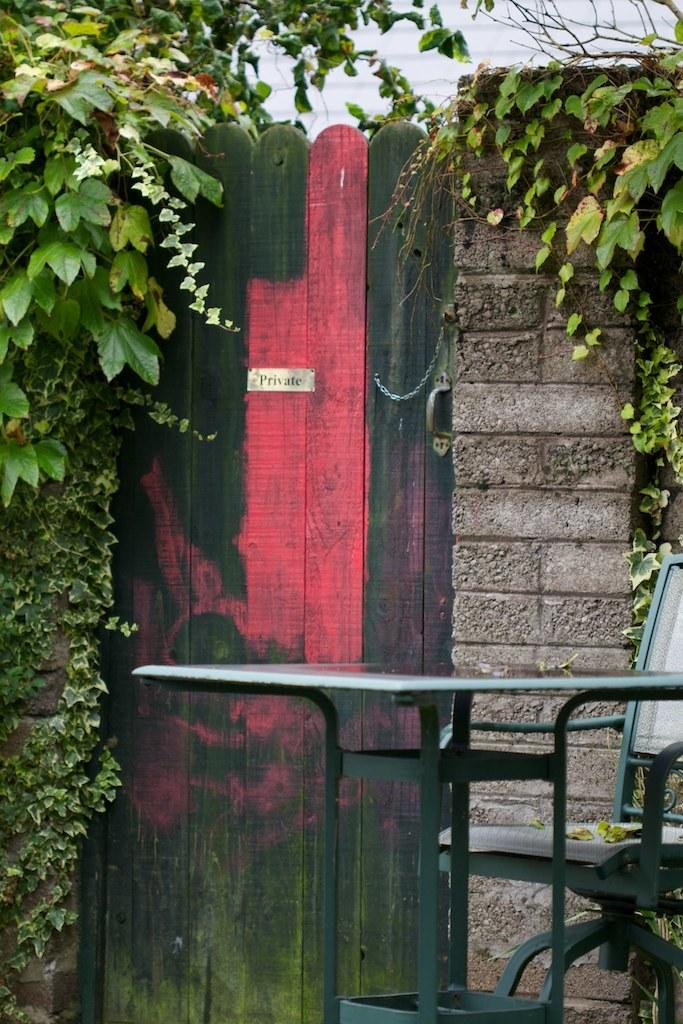What is the main object in the image? There is a door in the image. What is attached to the door? There is a chain on the door. How can the door be opened or closed? There is a door handle in the image. What can be seen on the left side of the image? There are plants on the left side of the image. What can be seen on the right side of the image? There are plants, a chair, and a table on the right side of the image. What type of neck accessory is being worn by the chair in the image? There is no neck accessory present in the image, as the chair is an inanimate object and cannot wear any accessories. 